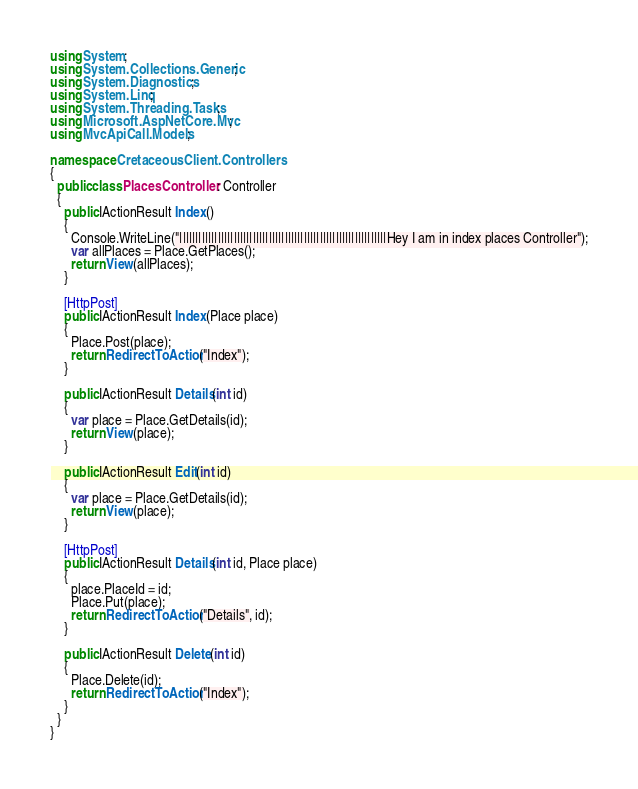Convert code to text. <code><loc_0><loc_0><loc_500><loc_500><_C#_>using System;
using System.Collections.Generic;
using System.Diagnostics;
using System.Linq;
using System.Threading.Tasks;
using Microsoft.AspNetCore.Mvc;
using MvcApiCall.Models;

namespace CretaceousClient.Controllers
{
  public class PlacesController : Controller
  {
    public IActionResult Index()
    {
      Console.WriteLine("|||||||||||||||||||||||||||||||||||||||||||||||||||||||||||||||||Hey I am in index places Controller");
      var allPlaces = Place.GetPlaces();
      return View(allPlaces);
    }

    [HttpPost]
    public IActionResult Index(Place place)
    {
      Place.Post(place);
      return RedirectToAction("Index");
    }

    public IActionResult Details(int id)
    {
      var place = Place.GetDetails(id);
      return View(place);
    }

    public IActionResult Edit(int id)
    {
      var place = Place.GetDetails(id);
      return View(place);
    }

    [HttpPost]
    public IActionResult Details(int id, Place place)
    {
      place.PlaceId = id;
      Place.Put(place);
      return RedirectToAction("Details", id);
    }

    public IActionResult Delete(int id)
    {
      Place.Delete(id);
      return RedirectToAction("Index");
    }
  }
}
</code> 